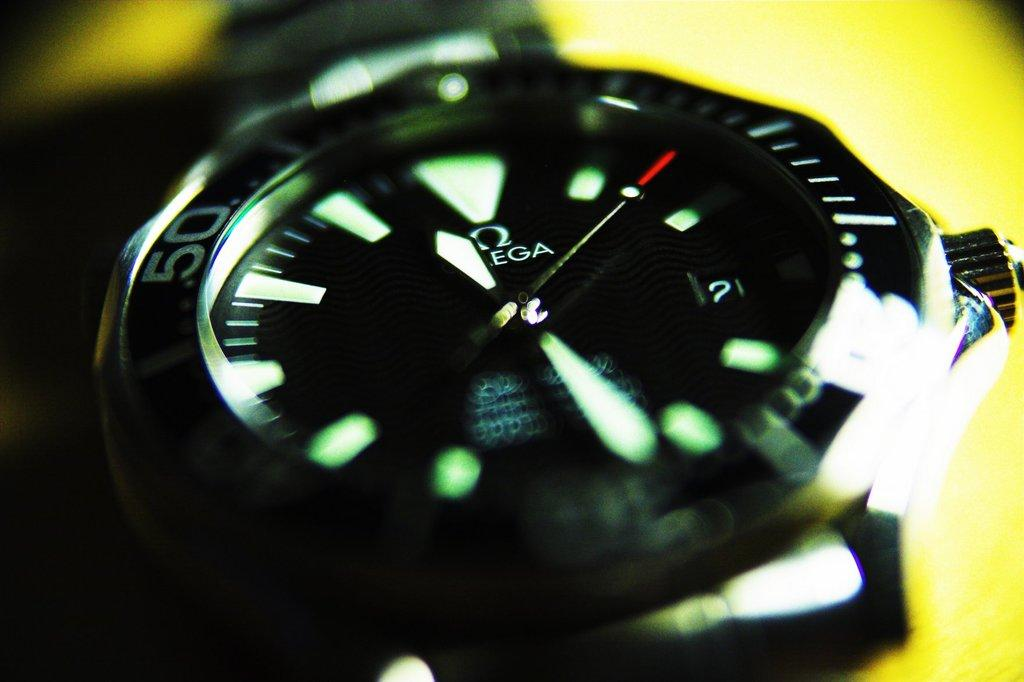<image>
Create a compact narrative representing the image presented. close up or omega wristwatch on a yellow background 